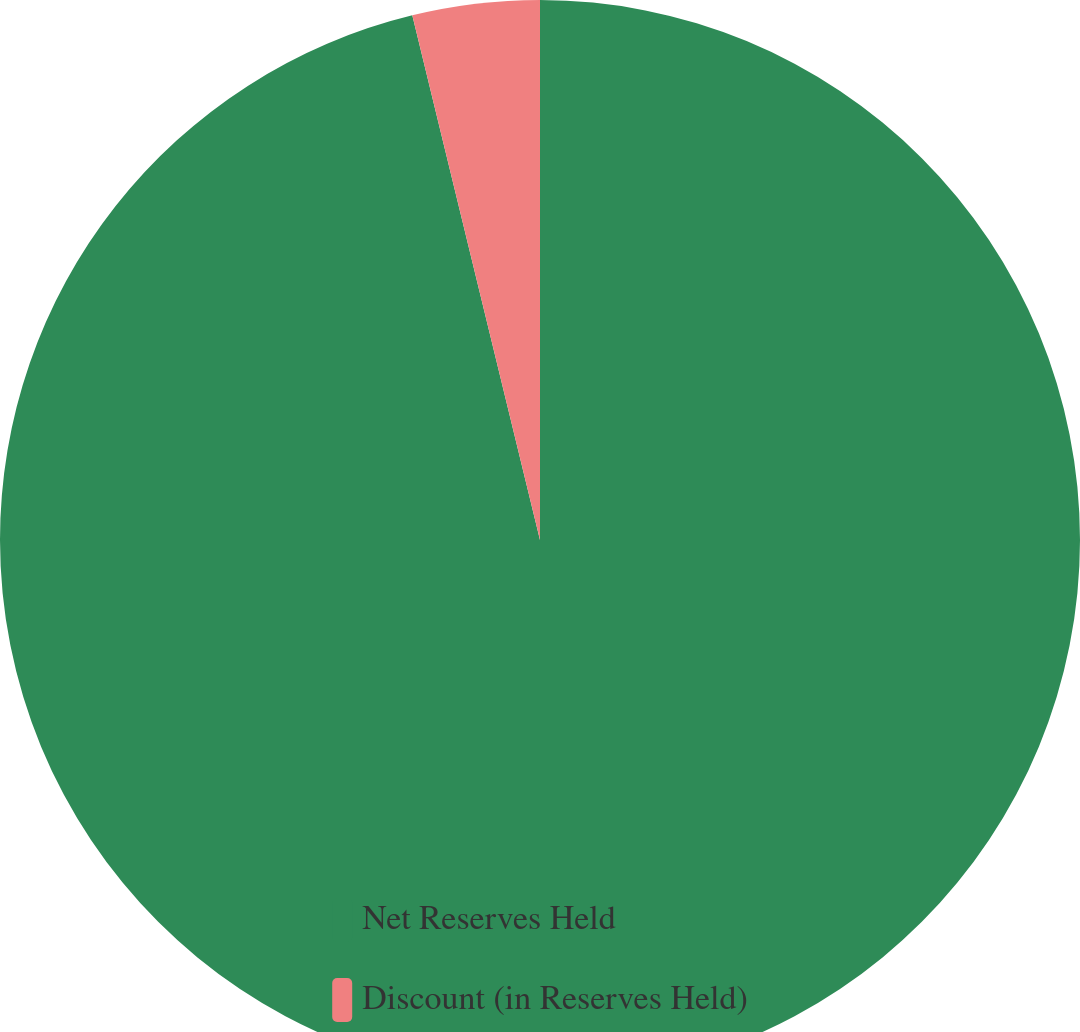Convert chart. <chart><loc_0><loc_0><loc_500><loc_500><pie_chart><fcel>Net Reserves Held<fcel>Discount (in Reserves Held)<nl><fcel>96.2%<fcel>3.8%<nl></chart> 